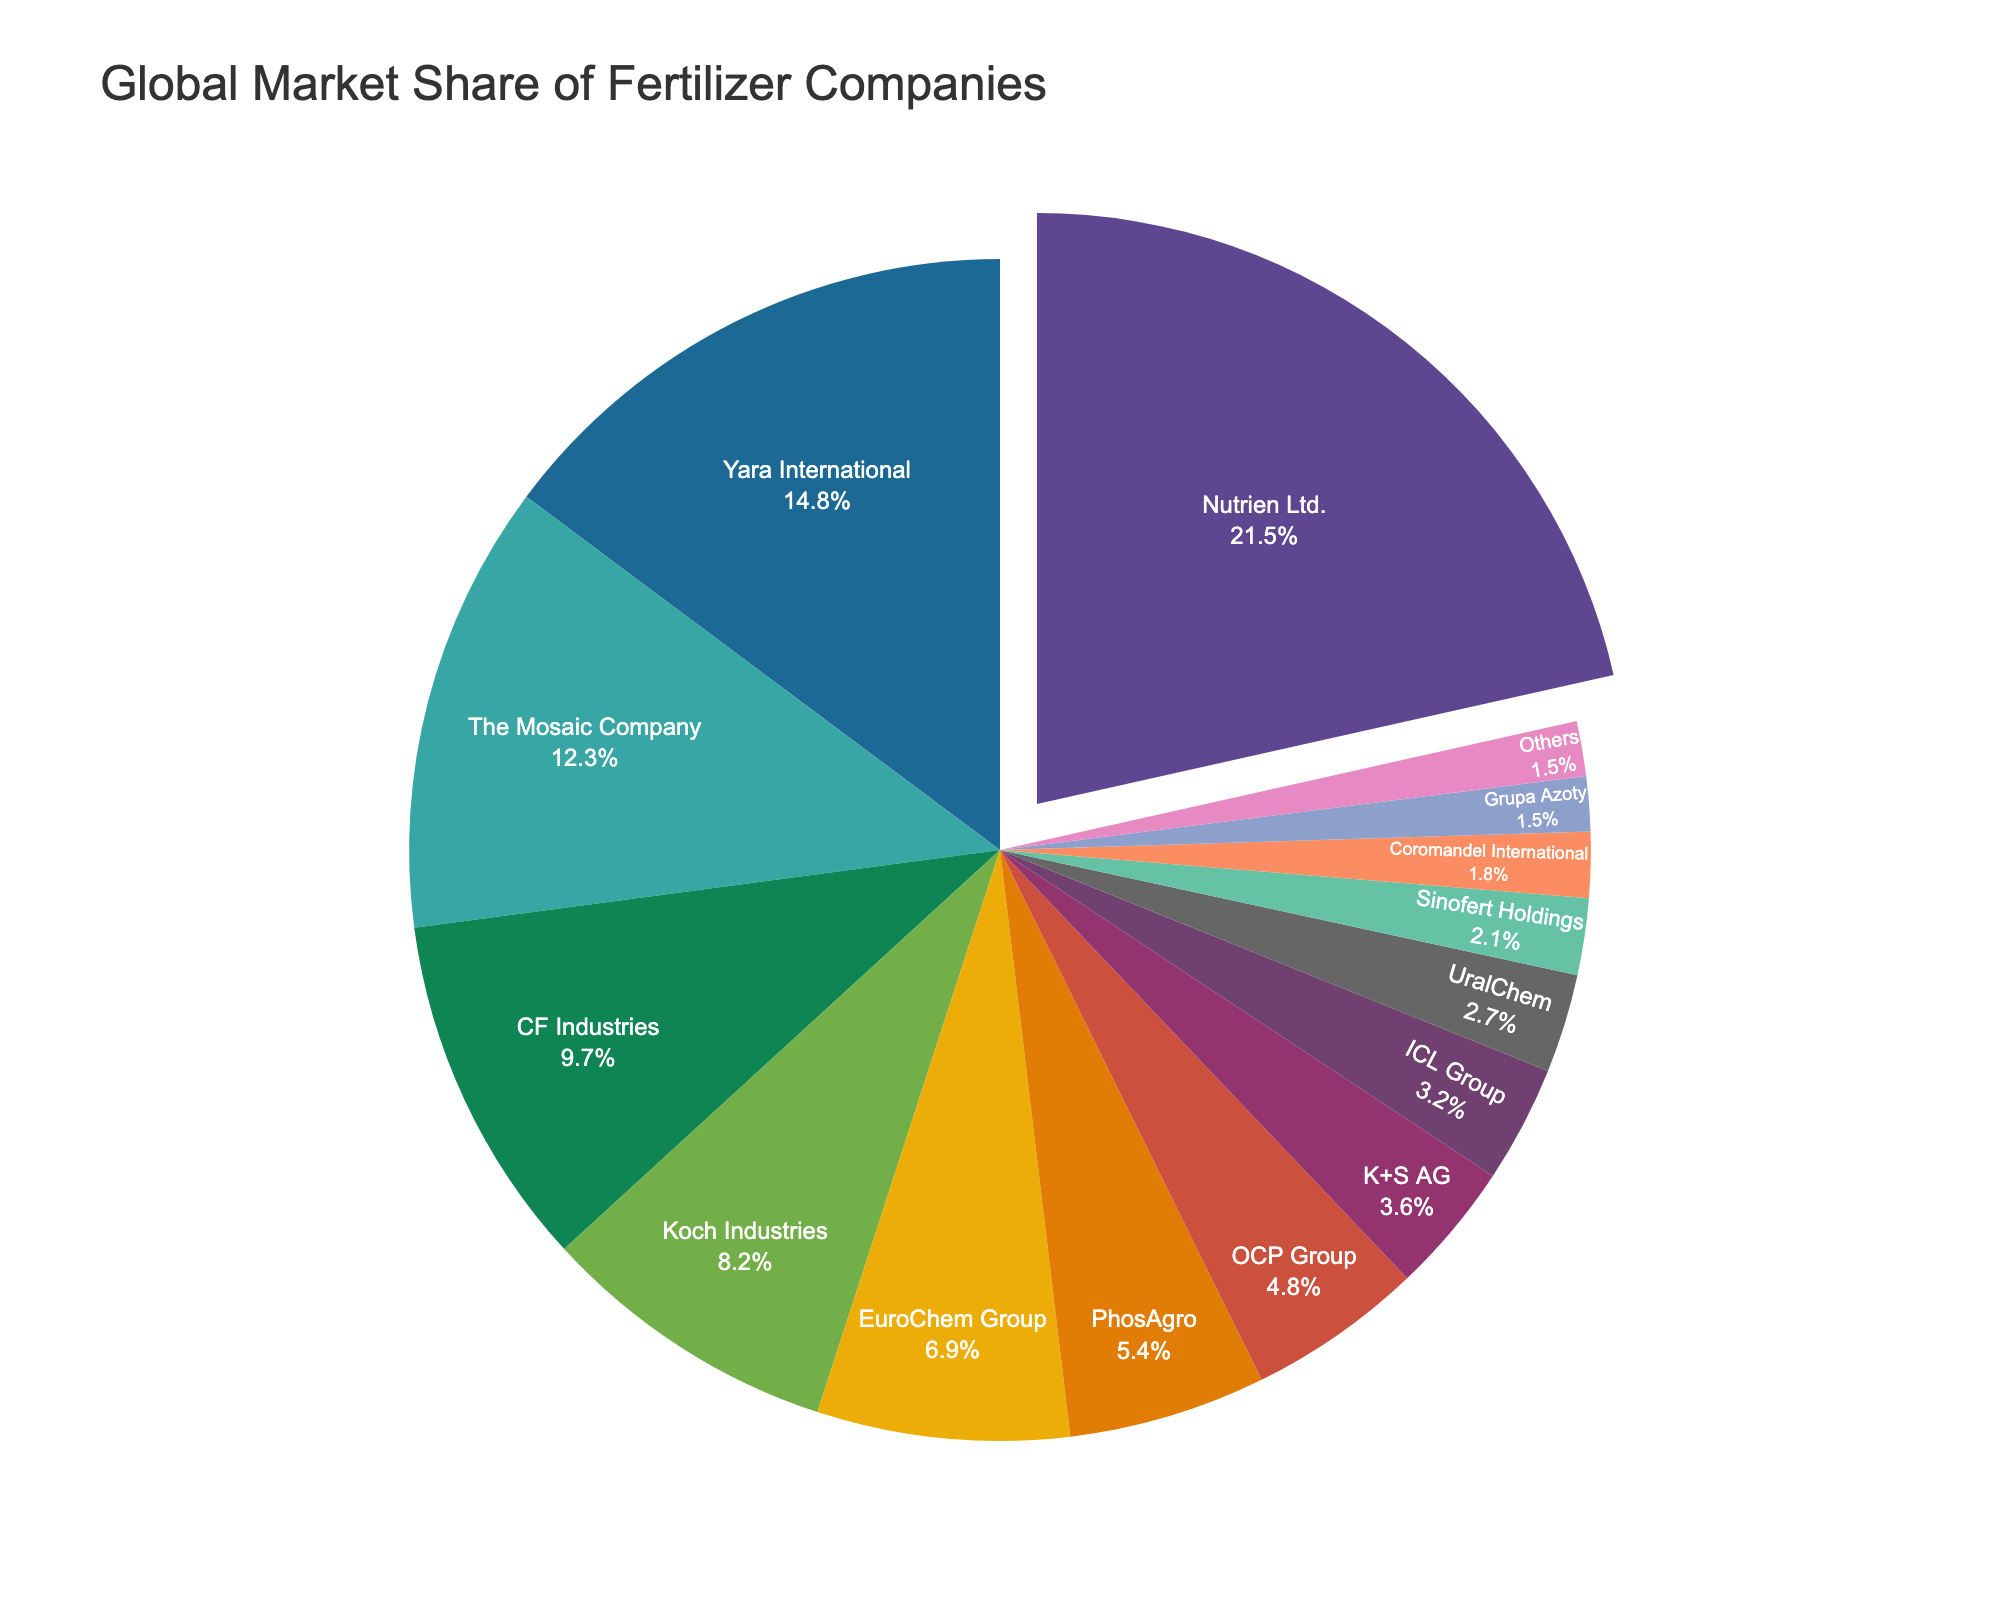What is the percentage market share of Nutrien Ltd.? Nutrien Ltd. has a market share of 21.5%, which is directly visible in the pie chart as a highlighted segment.
Answer: 21.5% Which company has the second largest market share, and what is it? The pie chart shows that Yara International has the second largest market share, which is 14.8%.
Answer: Yara International, 14.8% How much more market share does Nutrien Ltd. have compared to The Mosaic Company? Nutrien Ltd. has a 21.5% market share, and The Mosaic Company has a 12.3% market share. The difference is 21.5% - 12.3% = 9.2%.
Answer: 9.2% What is the combined market share of the top three companies? The top three companies are Nutrien Ltd. (21.5%), Yara International (14.8%), and The Mosaic Company (12.3%). Their combined market share is 21.5% + 14.8% + 12.3% = 48.6%.
Answer: 48.6% What is the average market share of Koch Industries, EuroChem Group, and PhosAgro? Koch Industries has a 8.2% market share, EuroChem Group has 6.9%, and PhosAgro has 5.4%. The average is (8.2% + 6.9% + 5.4%) / 3 = 20.5% / 3 ≈ 6.83%.
Answer: 6.83% Compare the market share of CF Industries to K+S AG. Which one is higher, and by how much? CF Industries (9.7%) has a higher market share than K+S AG (3.6%). The difference is 9.7% - 3.6% = 6.1%.
Answer: CF Industries by 6.1% How does the market share of 'Others' compare to each of the individual companies listed? 'Others' has a market share of 1.5%. All listed individual companies have a higher market share than 'Others'.
Answer: All listed companies have a higher market share What fraction of the market share do the bottom five companies represent? The bottom five companies are Sinofert Holdings (2.1%), Coromandel International (1.8%), Grupa Azoty (1.5%), and Others (1.5%). Their combined market share is 2.1% + 1.8% + 1.5% + 1.5% = 6.9%.
Answer: 6.9% Which company is visually highlighted in the pie chart, and what might be the reason for this? Nutrien Ltd. is visually highlighted by the pull effect in the pie chart, likely to emphasize its leading market share of 21.5%.
Answer: Nutrien Ltd 